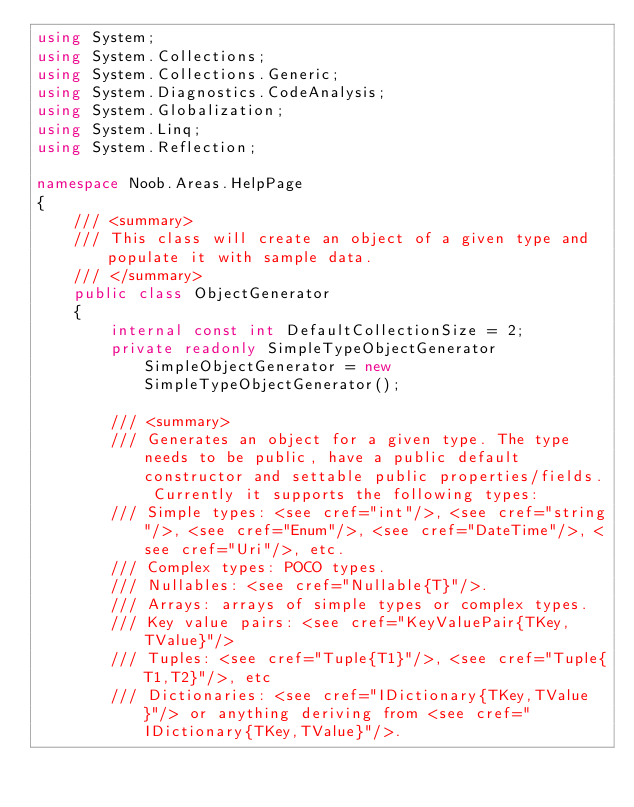Convert code to text. <code><loc_0><loc_0><loc_500><loc_500><_C#_>using System;
using System.Collections;
using System.Collections.Generic;
using System.Diagnostics.CodeAnalysis;
using System.Globalization;
using System.Linq;
using System.Reflection;

namespace Noob.Areas.HelpPage
{
    /// <summary>
    /// This class will create an object of a given type and populate it with sample data.
    /// </summary>
    public class ObjectGenerator
    {
        internal const int DefaultCollectionSize = 2;
        private readonly SimpleTypeObjectGenerator SimpleObjectGenerator = new SimpleTypeObjectGenerator();

        /// <summary>
        /// Generates an object for a given type. The type needs to be public, have a public default constructor and settable public properties/fields. Currently it supports the following types:
        /// Simple types: <see cref="int"/>, <see cref="string"/>, <see cref="Enum"/>, <see cref="DateTime"/>, <see cref="Uri"/>, etc.
        /// Complex types: POCO types.
        /// Nullables: <see cref="Nullable{T}"/>.
        /// Arrays: arrays of simple types or complex types.
        /// Key value pairs: <see cref="KeyValuePair{TKey,TValue}"/>
        /// Tuples: <see cref="Tuple{T1}"/>, <see cref="Tuple{T1,T2}"/>, etc
        /// Dictionaries: <see cref="IDictionary{TKey,TValue}"/> or anything deriving from <see cref="IDictionary{TKey,TValue}"/>.</code> 